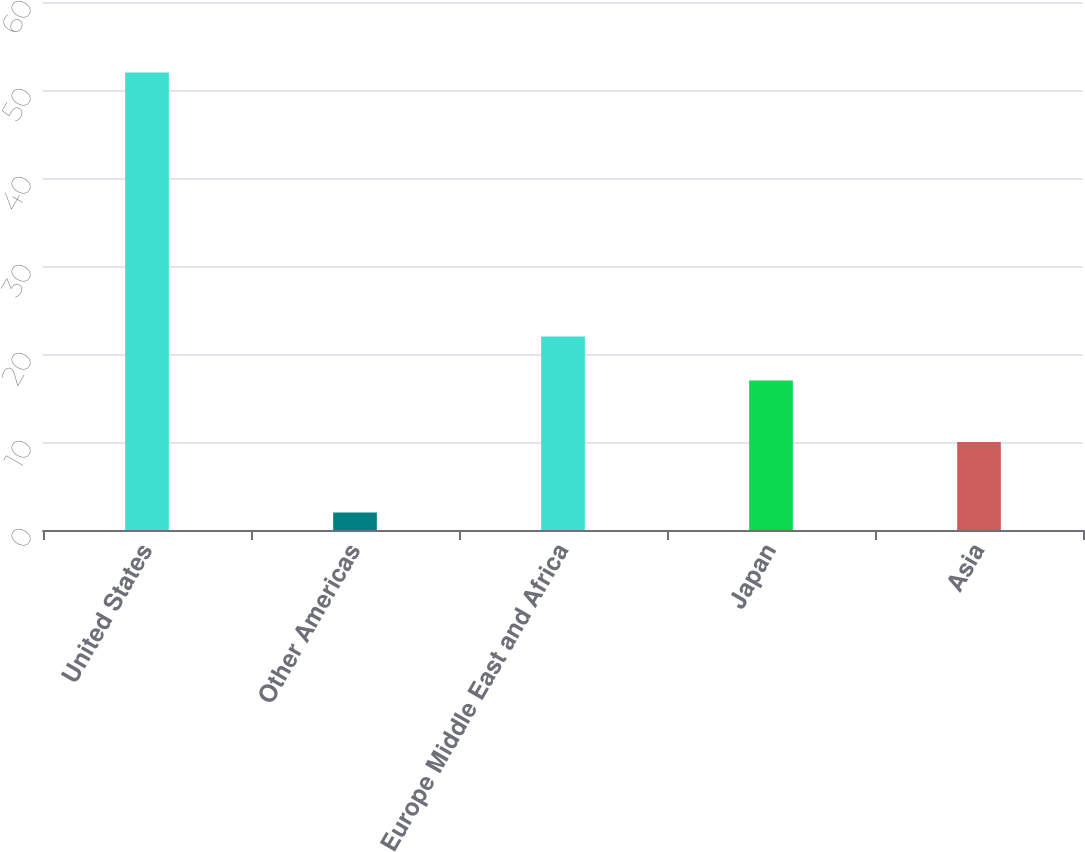Convert chart to OTSL. <chart><loc_0><loc_0><loc_500><loc_500><bar_chart><fcel>United States<fcel>Other Americas<fcel>Europe Middle East and Africa<fcel>Japan<fcel>Asia<nl><fcel>52<fcel>2<fcel>22<fcel>17<fcel>10<nl></chart> 